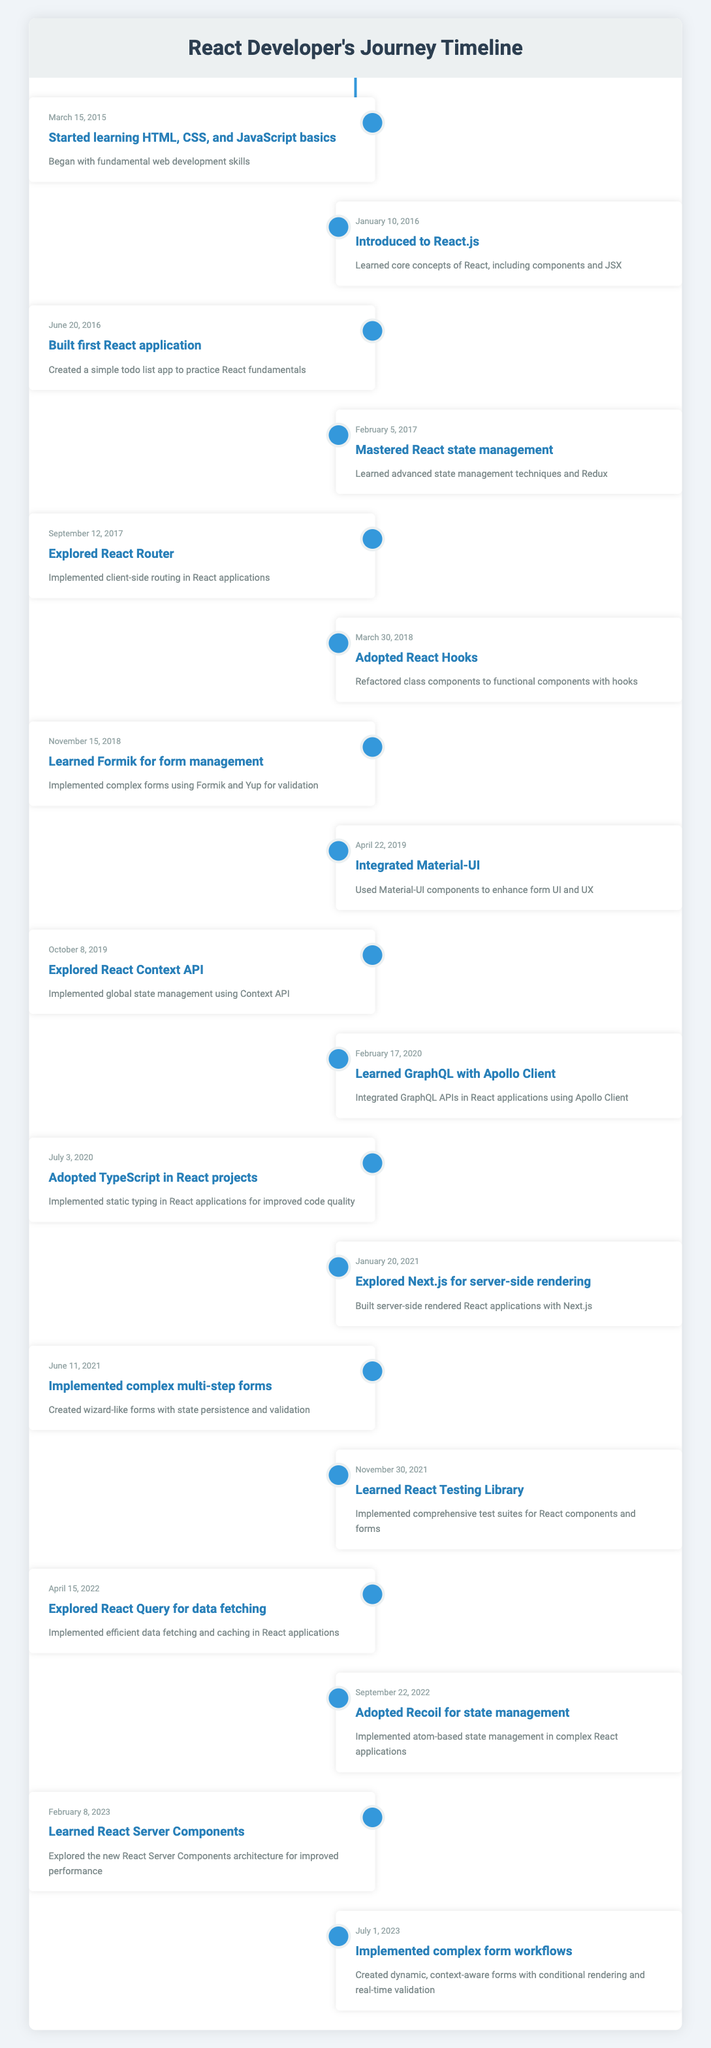What was the first event in the timeline? The first event listed is "Started learning HTML, CSS, and JavaScript basics," which is dated March 15, 2015. This can be found at the very top of the timeline.
Answer: Started learning HTML, CSS, and JavaScript basics Which event occurred in 2018? The events listed in 2018 are "Adopted React Hooks" on March 30 and "Learned Formik for form management" on November 15. Both events are within the year 2018.
Answer: Adopted React Hooks and Learned Formik for form management Did the developer learn GraphQL before or after adopting TypeScript? The developer learned GraphQL with Apollo Client on February 17, 2020, after adopting TypeScript on July 3, 2020. This can be established by comparing the dates of both events.
Answer: After How many events focused on form management are there? There are three events related to form management: "Learned Formik for form management" on November 15, 2018; "Implemented complex multi-step forms" on June 11, 2021; and "Implemented complex form workflows" on July 1, 2023. Counting these events gives us a total of three.
Answer: Three What was the median date of all the events in the timeline? To find the median date, first list all the event dates in chronological order: March 15, 2015; January 10, 2016; June 20, 2016; February 5, 2017; September 12, 2017; March 30, 2018; November 15, 2018; April 22, 2019; October 8, 2019; February 17, 2020; July 3, 2020; January 20, 2021; June 11, 2021; November 30, 2021; April 15, 2022; September 22, 2022; February 8, 2023; July 1, 2023. There are 18 dates, so the median will be the average of the 9th and 10th dates, which are October 8, 2019 and February 17, 2020. The median date is calculated as halfway between the two: (October 8, 2019 + February 17, 2020) results in a median date of about January 1, 2020.
Answer: January 1, 2020 When did the developer first explore a state management solution? The developer first explored a state management solution on February 5, 2017, with the event "Mastered React state management." This can be found under the relevant date in the table.
Answer: February 5, 2017 